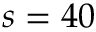<formula> <loc_0><loc_0><loc_500><loc_500>s = 4 0</formula> 